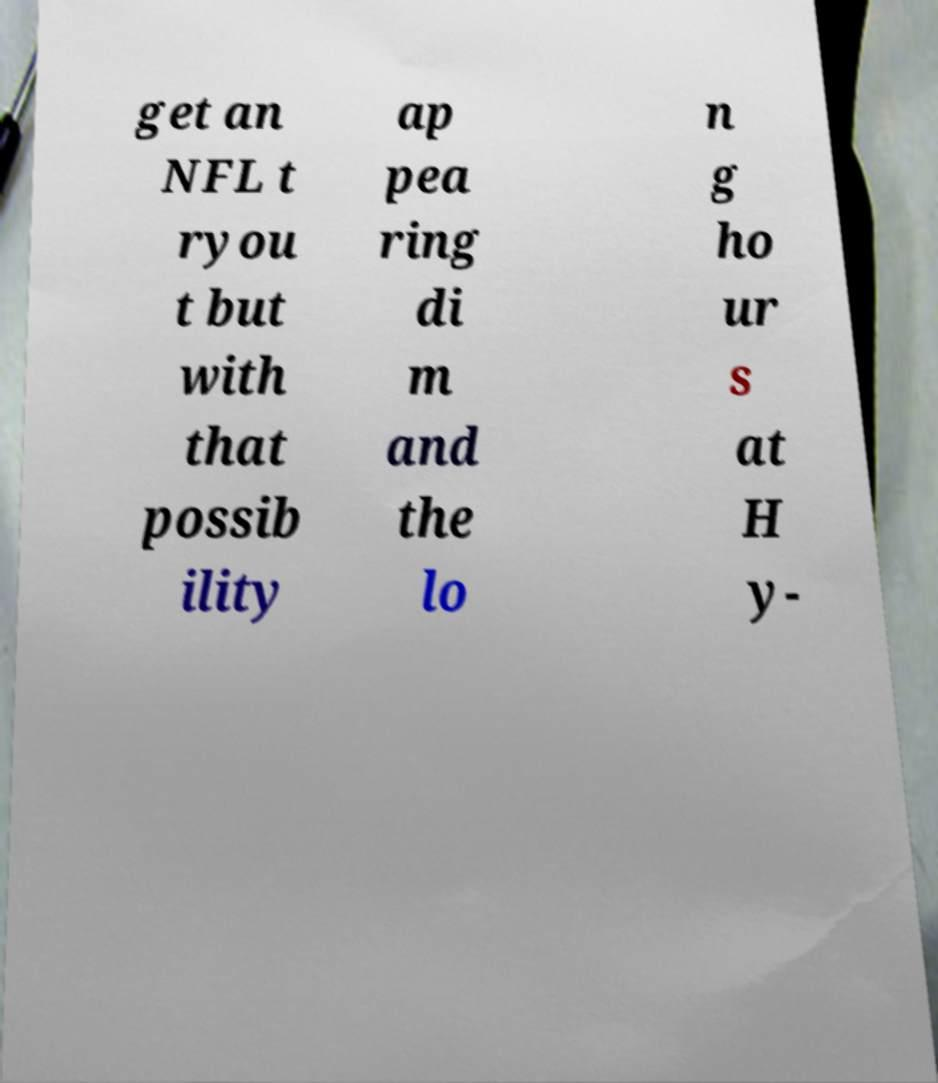Could you extract and type out the text from this image? get an NFL t ryou t but with that possib ility ap pea ring di m and the lo n g ho ur s at H y- 